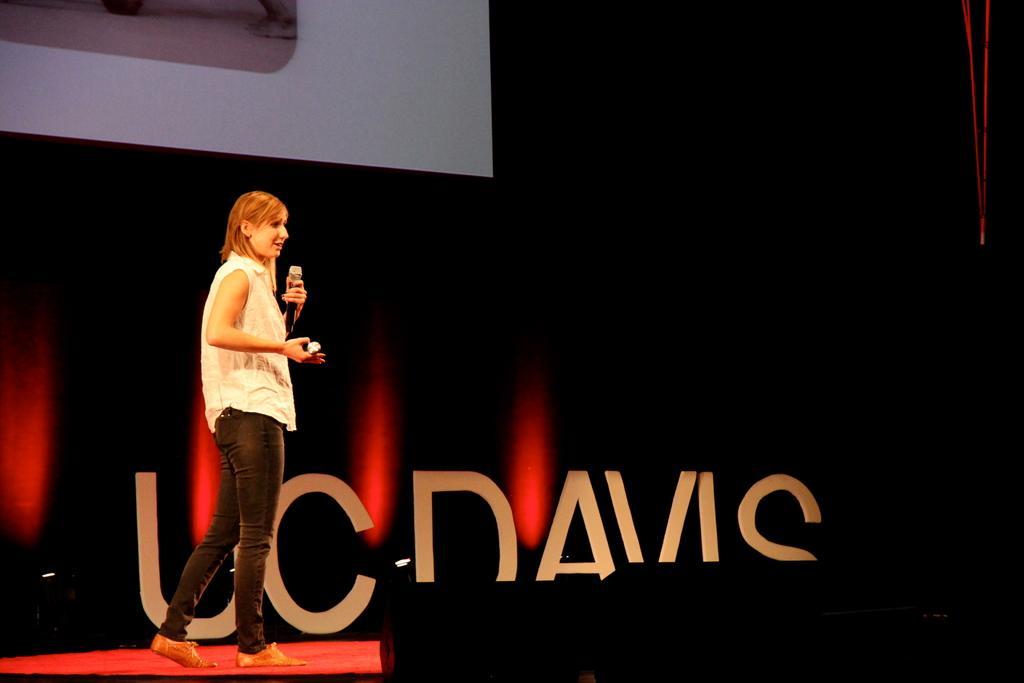How would you summarize this image in a sentence or two? In this picture we can see a woman is holding a microphone and she is explaining something. Behind the woman, there is a name board and the dark background. At the top of the image, there is a projector screen. 